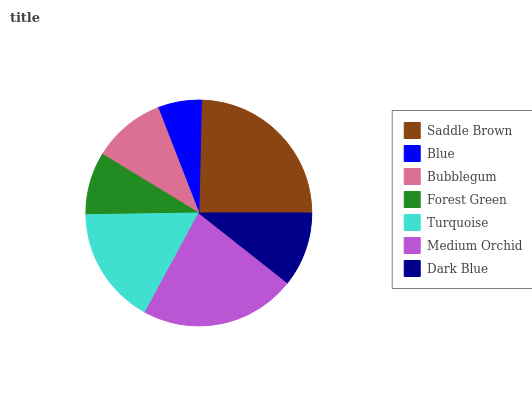Is Blue the minimum?
Answer yes or no. Yes. Is Saddle Brown the maximum?
Answer yes or no. Yes. Is Bubblegum the minimum?
Answer yes or no. No. Is Bubblegum the maximum?
Answer yes or no. No. Is Bubblegum greater than Blue?
Answer yes or no. Yes. Is Blue less than Bubblegum?
Answer yes or no. Yes. Is Blue greater than Bubblegum?
Answer yes or no. No. Is Bubblegum less than Blue?
Answer yes or no. No. Is Dark Blue the high median?
Answer yes or no. Yes. Is Dark Blue the low median?
Answer yes or no. Yes. Is Blue the high median?
Answer yes or no. No. Is Bubblegum the low median?
Answer yes or no. No. 